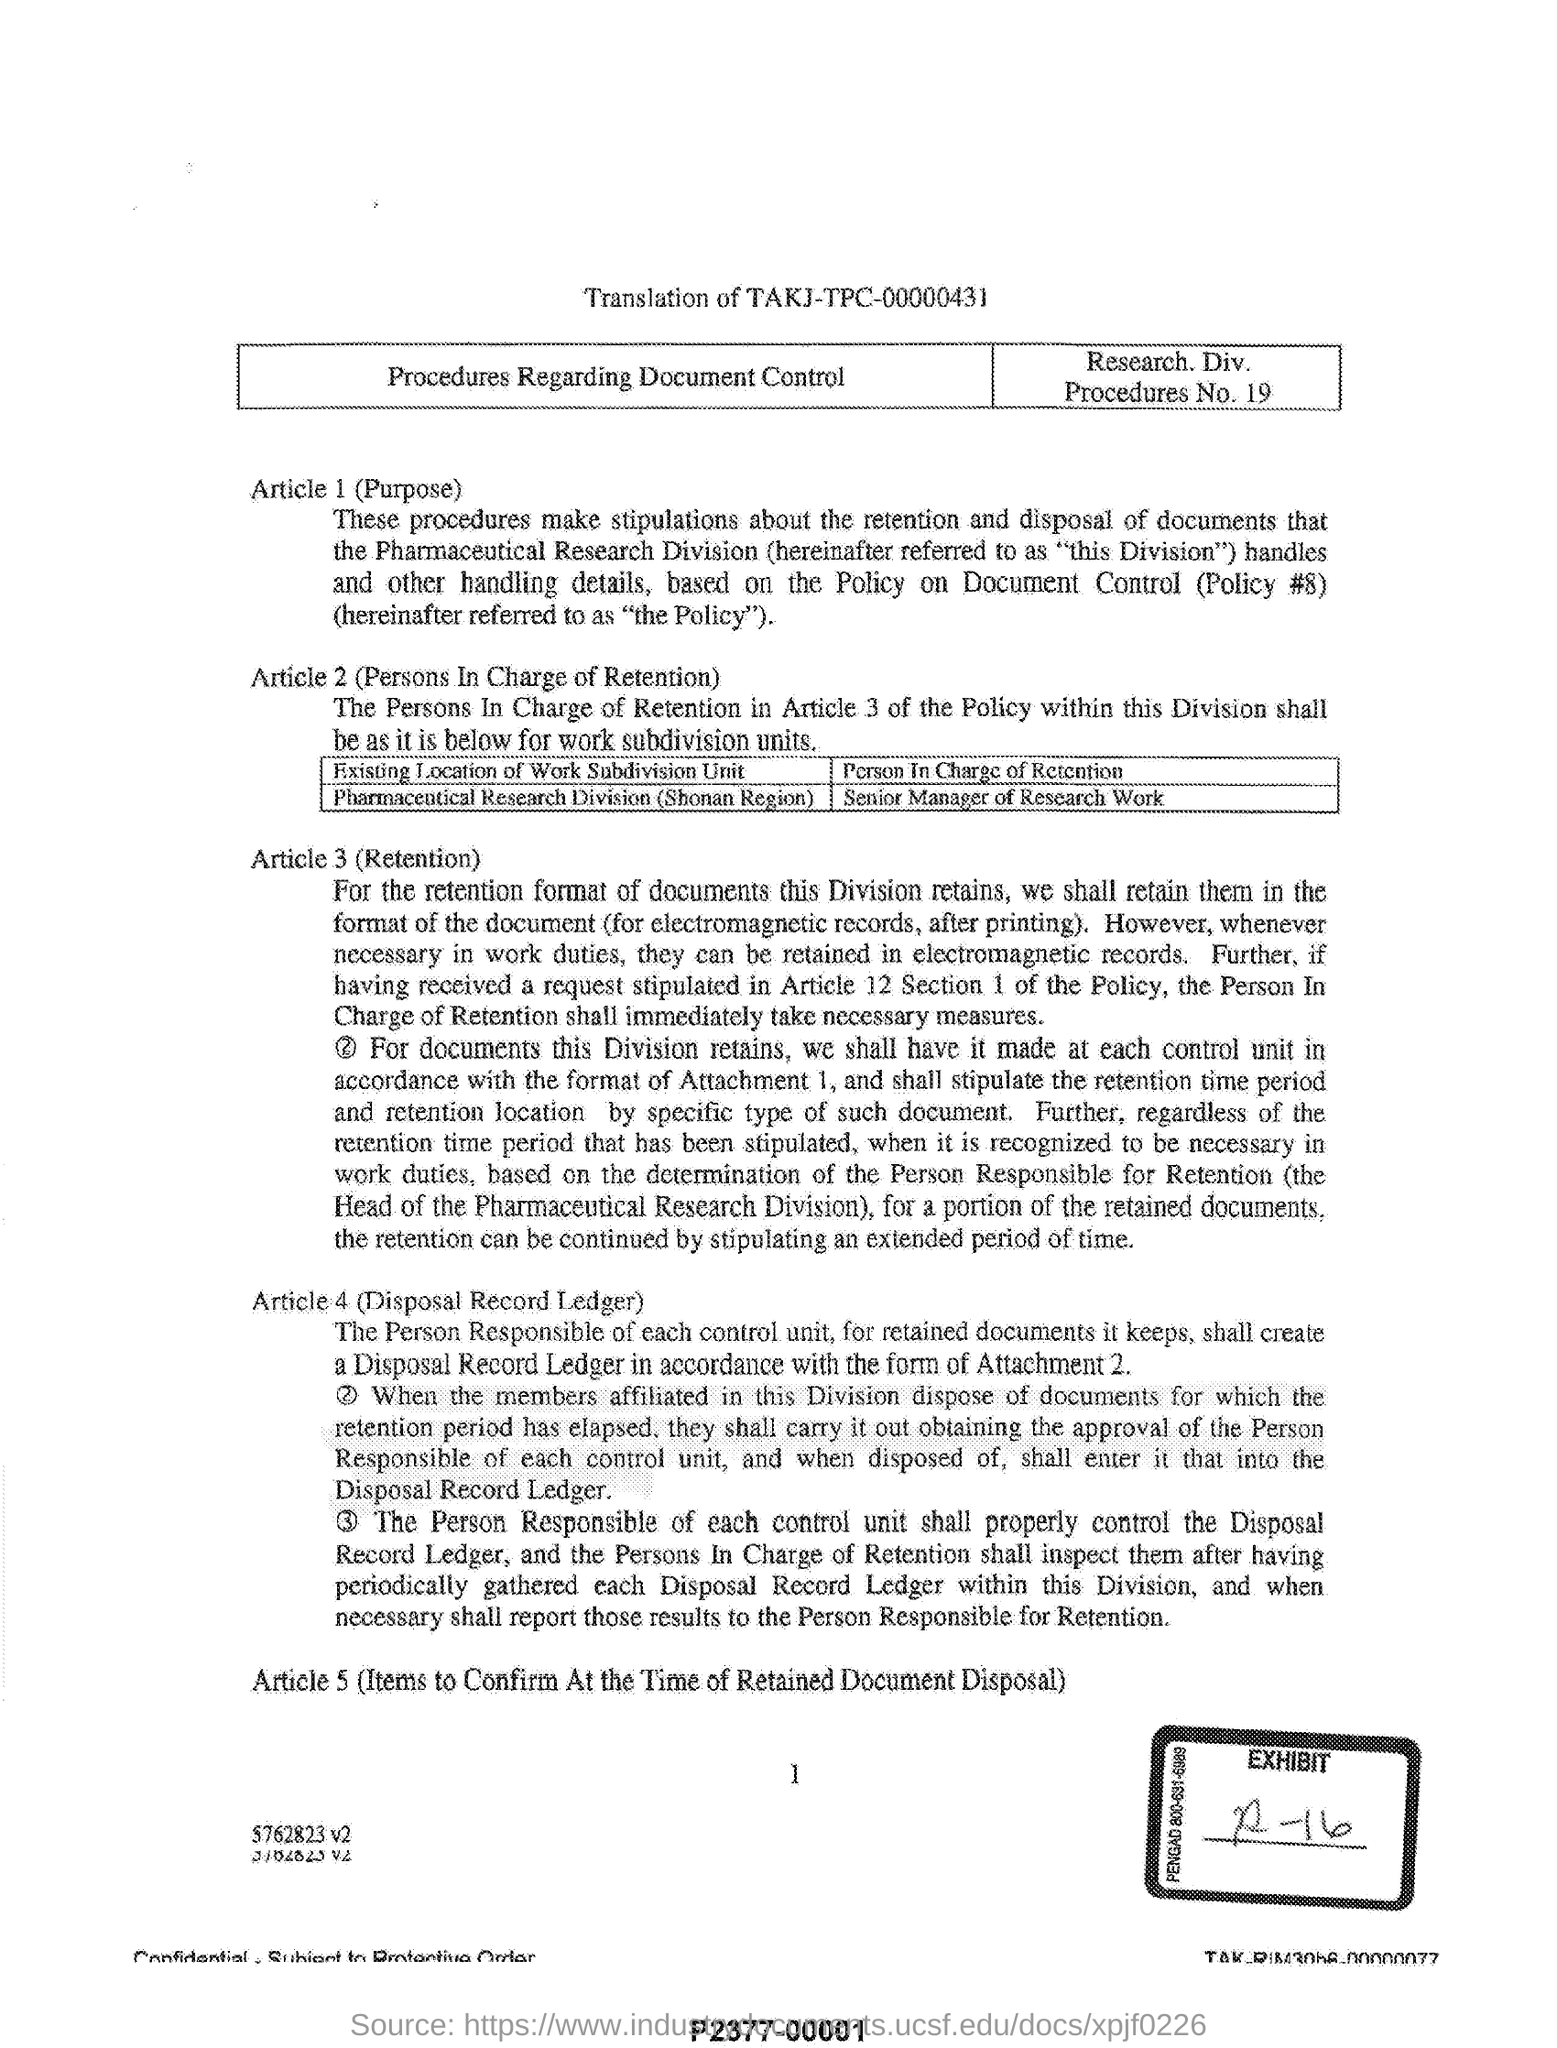Indicate a few pertinent items in this graphic. Article 4 in this document refers to the Disposal Record Ledger. In Article 2, the persons in charge of retention are described. The description of Procedure No. 19 is being provided here. 